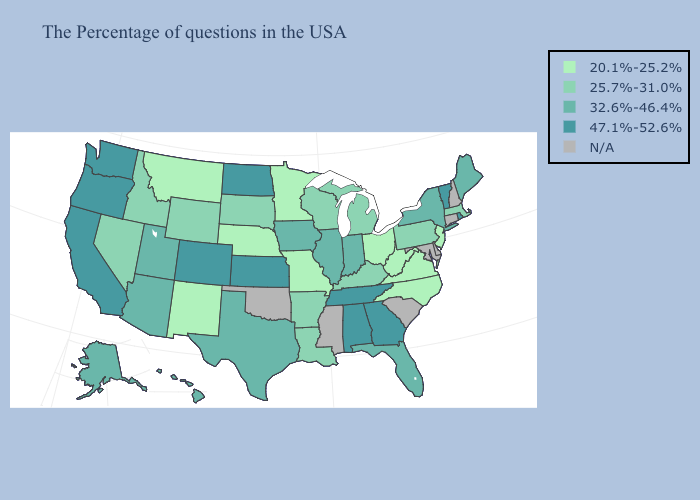What is the value of Nebraska?
Short answer required. 20.1%-25.2%. What is the highest value in states that border Vermont?
Write a very short answer. 32.6%-46.4%. What is the lowest value in states that border Georgia?
Be succinct. 20.1%-25.2%. What is the highest value in the South ?
Quick response, please. 47.1%-52.6%. Among the states that border North Dakota , does Montana have the lowest value?
Answer briefly. Yes. How many symbols are there in the legend?
Concise answer only. 5. What is the value of Wyoming?
Concise answer only. 25.7%-31.0%. Among the states that border North Dakota , does South Dakota have the highest value?
Write a very short answer. Yes. Name the states that have a value in the range 25.7%-31.0%?
Quick response, please. Massachusetts, Pennsylvania, Michigan, Kentucky, Wisconsin, Louisiana, Arkansas, South Dakota, Wyoming, Idaho, Nevada. What is the highest value in the South ?
Be succinct. 47.1%-52.6%. Which states have the lowest value in the USA?
Give a very brief answer. New Jersey, Virginia, North Carolina, West Virginia, Ohio, Missouri, Minnesota, Nebraska, New Mexico, Montana. Does Oregon have the highest value in the USA?
Give a very brief answer. Yes. 